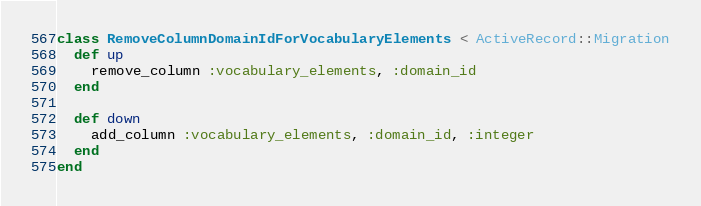<code> <loc_0><loc_0><loc_500><loc_500><_Ruby_>class RemoveColumnDomainIdForVocabularyElements < ActiveRecord::Migration
  def up
    remove_column :vocabulary_elements, :domain_id
  end
  
  def down
    add_column :vocabulary_elements, :domain_id, :integer
  end
end
</code> 